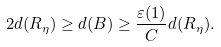<formula> <loc_0><loc_0><loc_500><loc_500>2 d ( R _ { \eta } ) \geq d ( B ) \geq \frac { \varepsilon ( 1 ) } C d ( R _ { \eta } ) .</formula> 